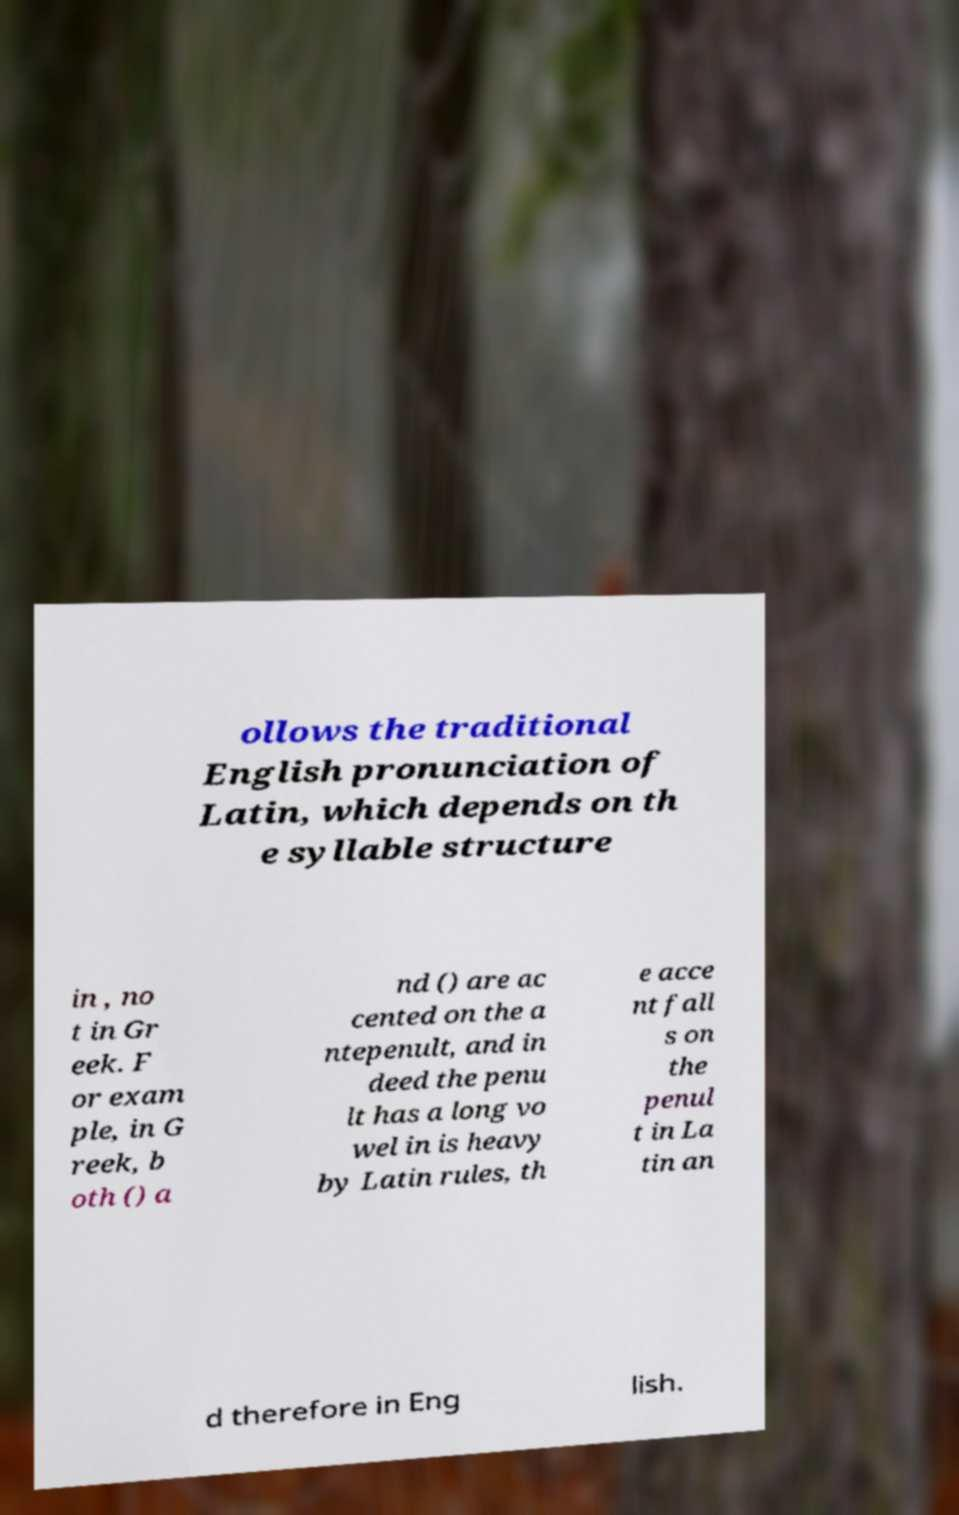Please read and relay the text visible in this image. What does it say? ollows the traditional English pronunciation of Latin, which depends on th e syllable structure in , no t in Gr eek. F or exam ple, in G reek, b oth () a nd () are ac cented on the a ntepenult, and in deed the penu lt has a long vo wel in is heavy by Latin rules, th e acce nt fall s on the penul t in La tin an d therefore in Eng lish. 